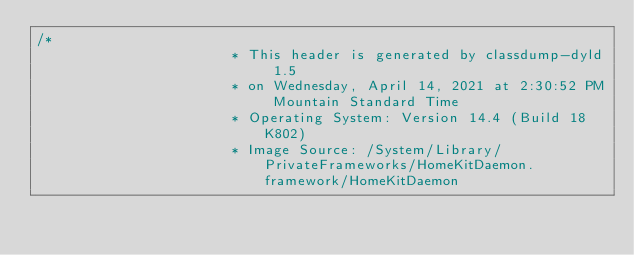<code> <loc_0><loc_0><loc_500><loc_500><_C_>/*
                       * This header is generated by classdump-dyld 1.5
                       * on Wednesday, April 14, 2021 at 2:30:52 PM Mountain Standard Time
                       * Operating System: Version 14.4 (Build 18K802)
                       * Image Source: /System/Library/PrivateFrameworks/HomeKitDaemon.framework/HomeKitDaemon</code> 